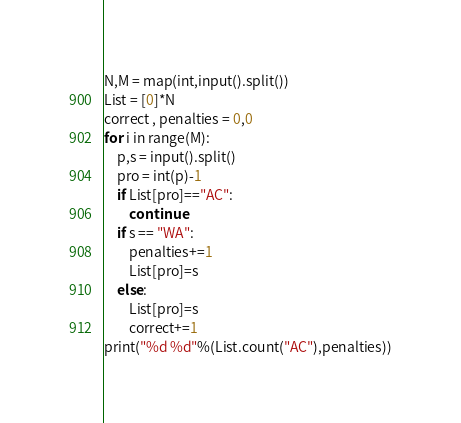<code> <loc_0><loc_0><loc_500><loc_500><_Python_>N,M = map(int,input().split())
List = [0]*N
correct , penalties = 0,0
for i in range(M):
    p,s = input().split()
    pro = int(p)-1
    if List[pro]=="AC":
        continue
    if s == "WA":
        penalties+=1
        List[pro]=s
    else:
        List[pro]=s
        correct+=1
print("%d %d"%(List.count("AC"),penalties))</code> 